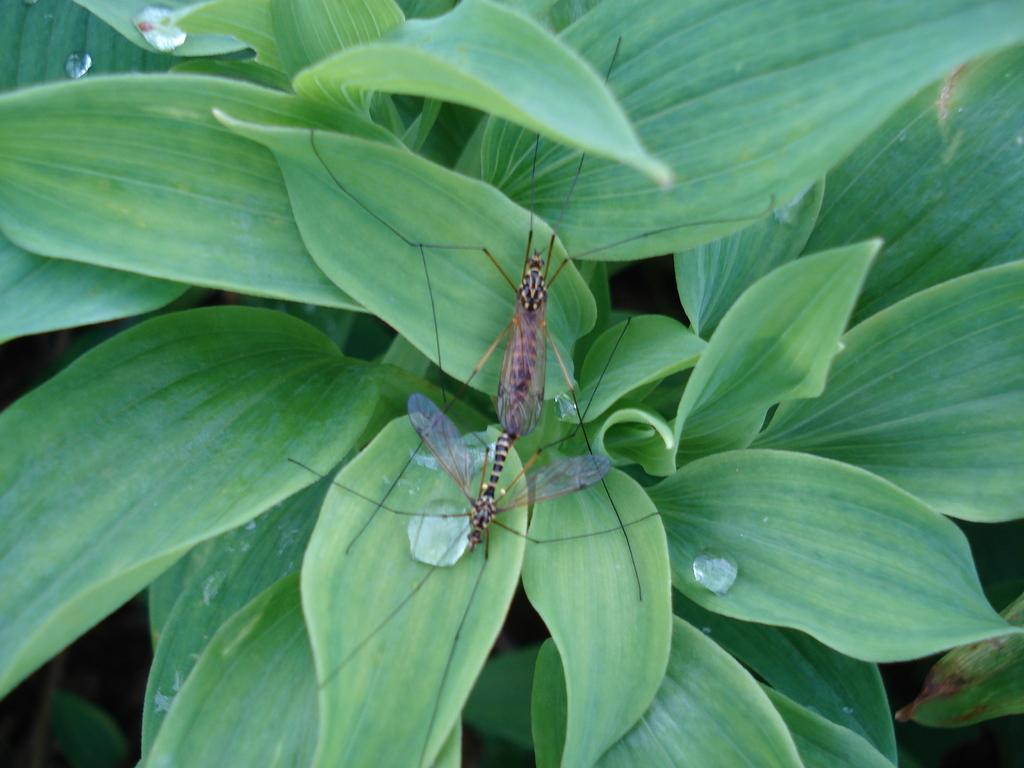What type of creatures can be seen on the leaves in the image? There are insects present on the leaves in the image. What else can be observed on the leaves in the image? There are water drops on the leaves in the image. What type of cracker is visible on the leaves in the image? There is no cracker present on the leaves in the image. What type of mass is causing the disease on the leaves in the image? There is no disease present on the leaves in the image. 